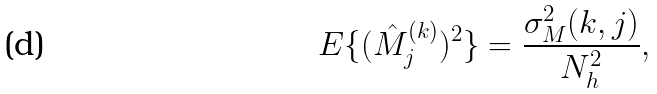<formula> <loc_0><loc_0><loc_500><loc_500>E \{ ( \hat { M } _ { j } ^ { ( k ) } ) ^ { 2 } \} = \frac { \sigma _ { M } ^ { 2 } ( k , j ) } { N _ { h } ^ { 2 } } ,</formula> 